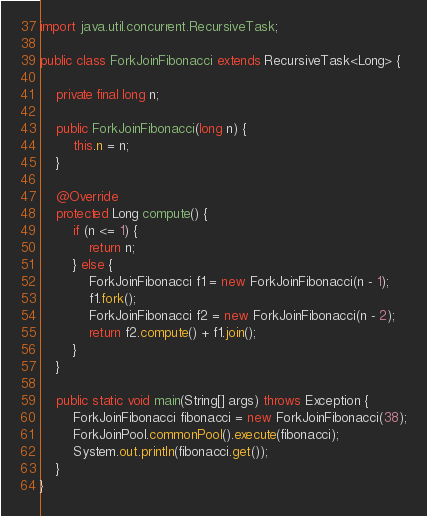<code> <loc_0><loc_0><loc_500><loc_500><_Java_>import java.util.concurrent.RecursiveTask;

public class ForkJoinFibonacci extends RecursiveTask<Long> {

    private final long n;

    public ForkJoinFibonacci(long n) {
        this.n = n;
    }

    @Override
    protected Long compute() {
        if (n <= 1) {
            return n;
        } else {
            ForkJoinFibonacci f1 = new ForkJoinFibonacci(n - 1);
            f1.fork();
            ForkJoinFibonacci f2 = new ForkJoinFibonacci(n - 2);
            return f2.compute() + f1.join();
        }
    }

    public static void main(String[] args) throws Exception {
        ForkJoinFibonacci fibonacci = new ForkJoinFibonacci(38);
        ForkJoinPool.commonPool().execute(fibonacci);
        System.out.println(fibonacci.get());
    }
}
</code> 